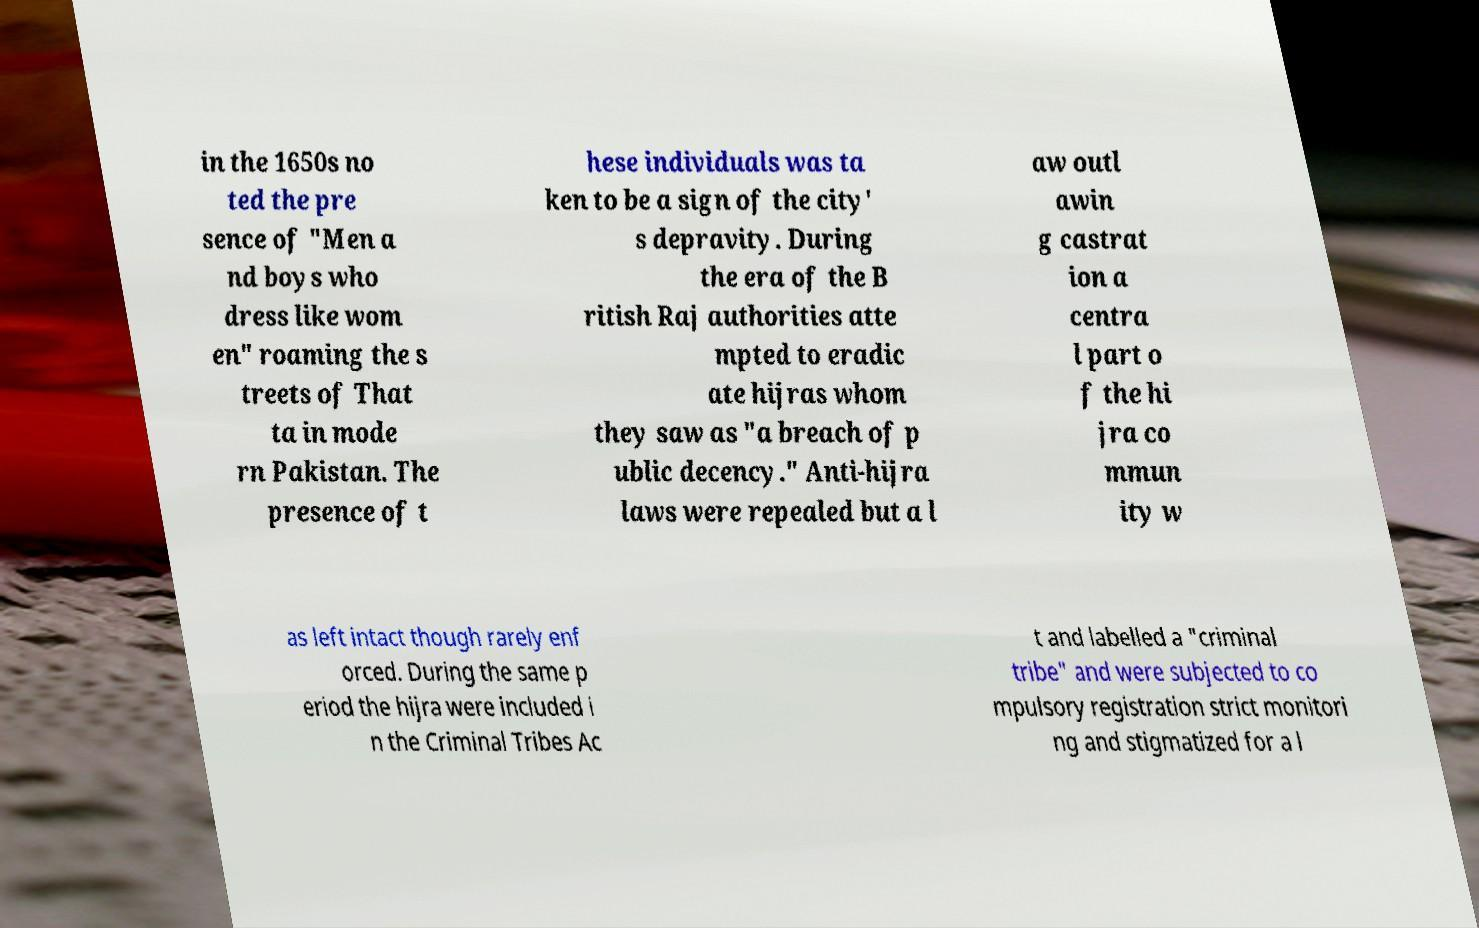Can you accurately transcribe the text from the provided image for me? in the 1650s no ted the pre sence of "Men a nd boys who dress like wom en" roaming the s treets of That ta in mode rn Pakistan. The presence of t hese individuals was ta ken to be a sign of the city' s depravity. During the era of the B ritish Raj authorities atte mpted to eradic ate hijras whom they saw as "a breach of p ublic decency." Anti-hijra laws were repealed but a l aw outl awin g castrat ion a centra l part o f the hi jra co mmun ity w as left intact though rarely enf orced. During the same p eriod the hijra were included i n the Criminal Tribes Ac t and labelled a "criminal tribe" and were subjected to co mpulsory registration strict monitori ng and stigmatized for a l 